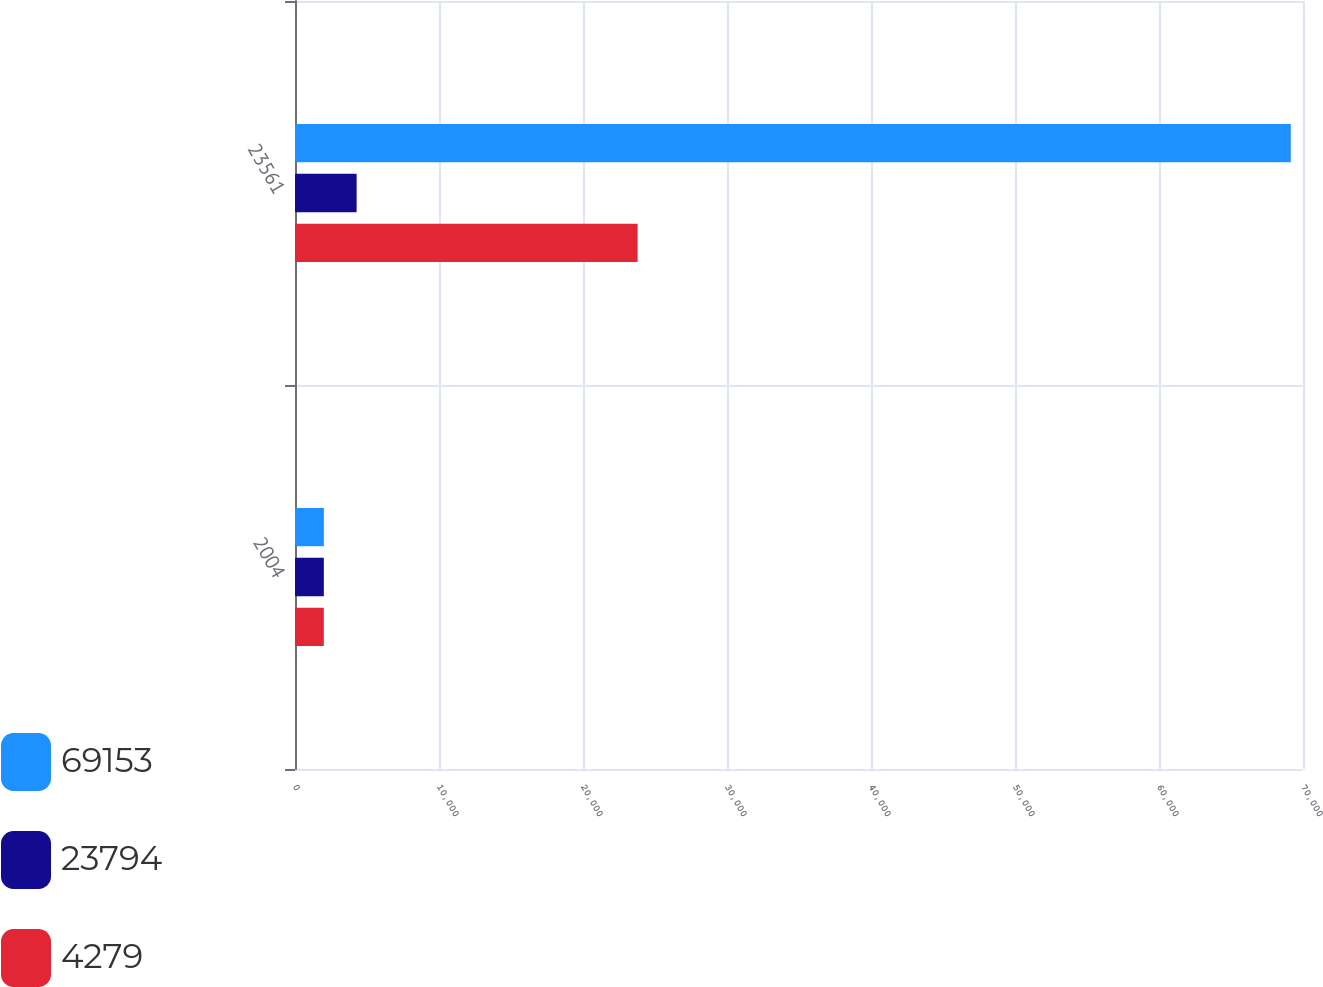<chart> <loc_0><loc_0><loc_500><loc_500><stacked_bar_chart><ecel><fcel>2004<fcel>23561<nl><fcel>69153<fcel>2003<fcel>69153<nl><fcel>23794<fcel>2002<fcel>4279<nl><fcel>4279<fcel>2001<fcel>23794<nl></chart> 